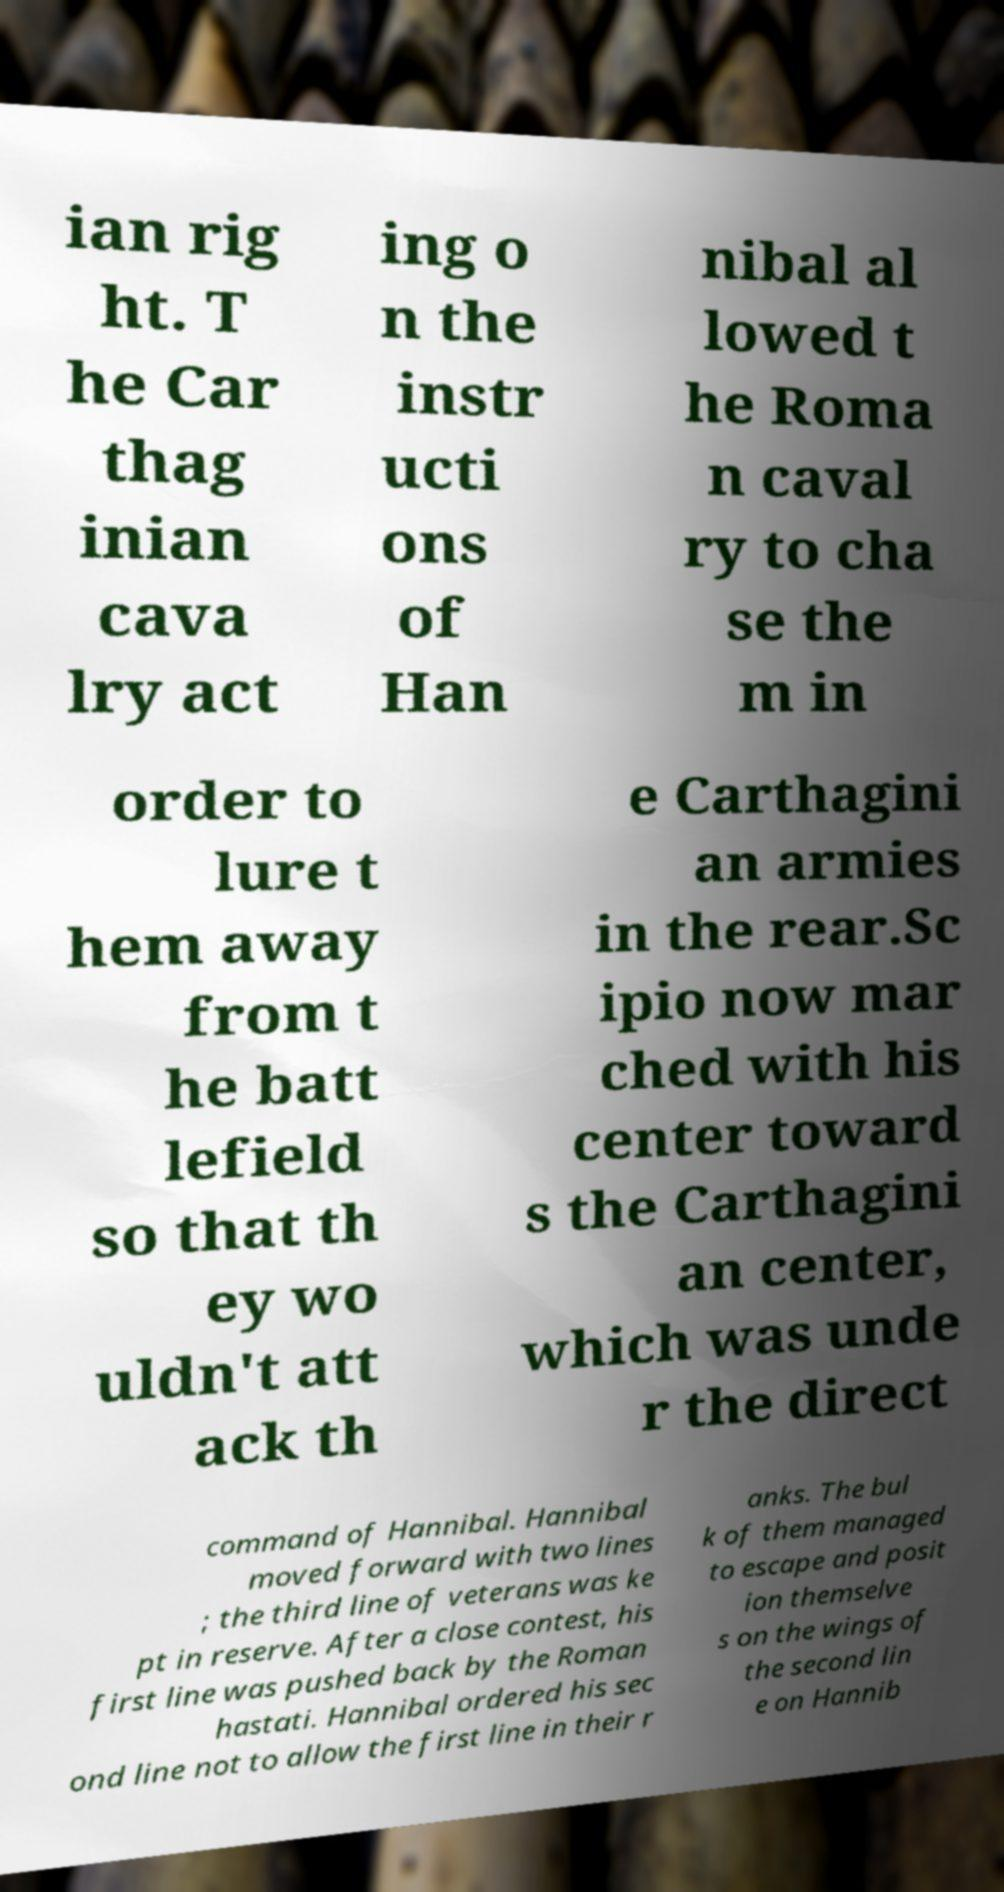Can you accurately transcribe the text from the provided image for me? ian rig ht. T he Car thag inian cava lry act ing o n the instr ucti ons of Han nibal al lowed t he Roma n caval ry to cha se the m in order to lure t hem away from t he batt lefield so that th ey wo uldn't att ack th e Carthagini an armies in the rear.Sc ipio now mar ched with his center toward s the Carthagini an center, which was unde r the direct command of Hannibal. Hannibal moved forward with two lines ; the third line of veterans was ke pt in reserve. After a close contest, his first line was pushed back by the Roman hastati. Hannibal ordered his sec ond line not to allow the first line in their r anks. The bul k of them managed to escape and posit ion themselve s on the wings of the second lin e on Hannib 